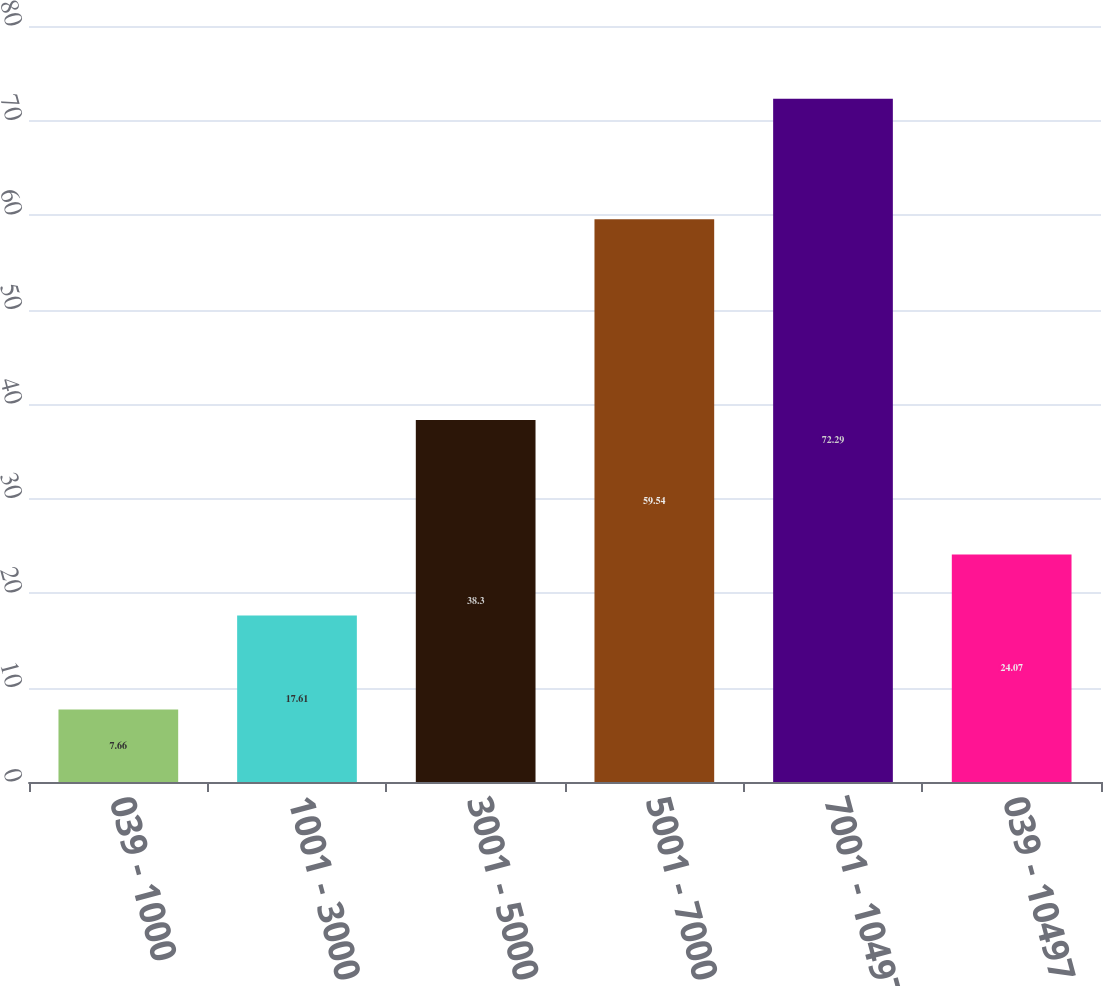Convert chart. <chart><loc_0><loc_0><loc_500><loc_500><bar_chart><fcel>039 - 1000<fcel>1001 - 3000<fcel>3001 - 5000<fcel>5001 - 7000<fcel>7001 - 10497<fcel>039 - 10497<nl><fcel>7.66<fcel>17.61<fcel>38.3<fcel>59.54<fcel>72.29<fcel>24.07<nl></chart> 